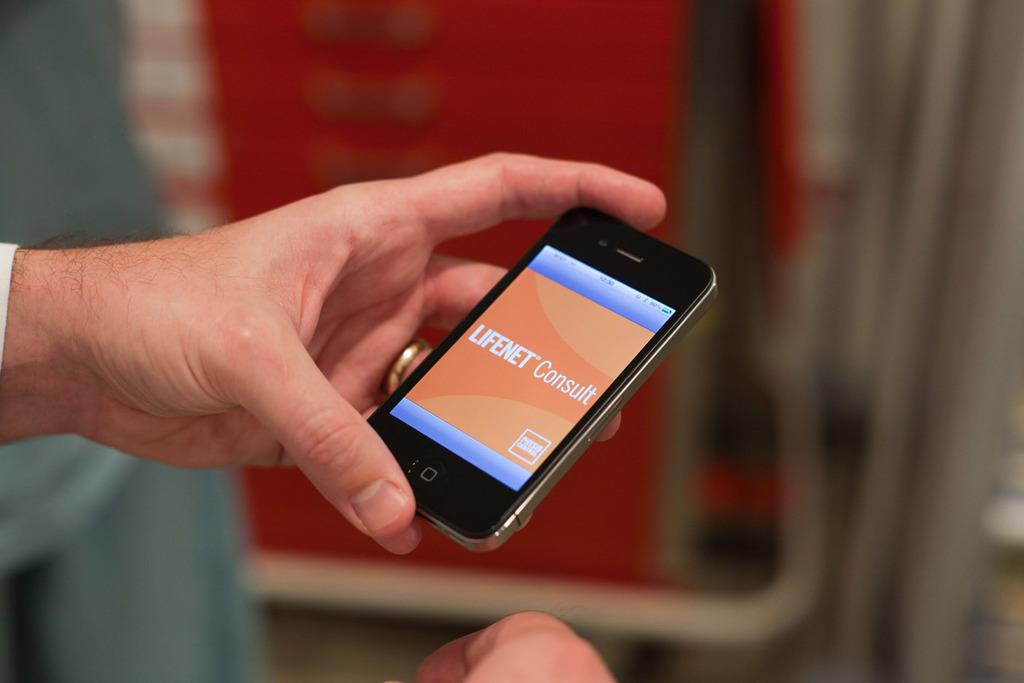<image>
Offer a succinct explanation of the picture presented. An iPhone connected to the internet displays the message LIFENET Consult. 